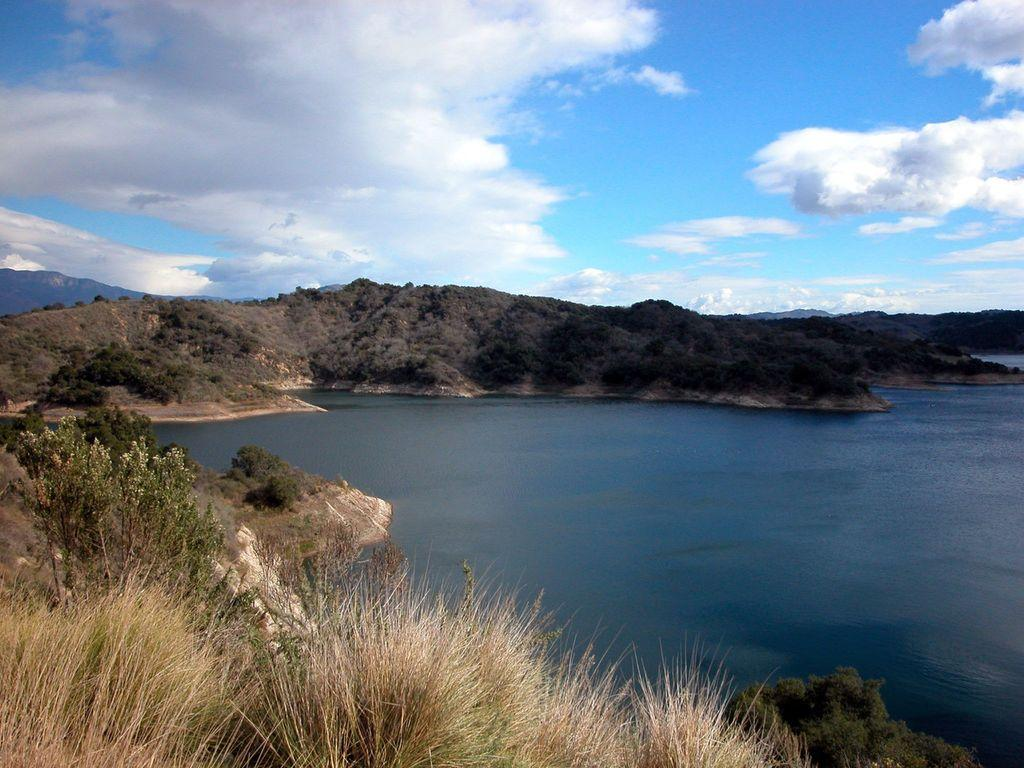What type of body of water is in the image? There is a lake in the image. What can be seen in front of the lake? Trees are present in front of the lake. What other geographical features are visible in the image? There are hills visible in the image. What is visible above the lake and hills? The sky is visible in the image. What can be observed in the sky? Clouds are present in the sky. What type of insect can be seen having an effect on the lake in the image? There is no insect present in the image, and therefore no effect on the lake can be observed. 